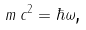Convert formula to latex. <formula><loc_0><loc_0><loc_500><loc_500>m \, c ^ { 2 } = \hbar { \omega } \text {,}</formula> 